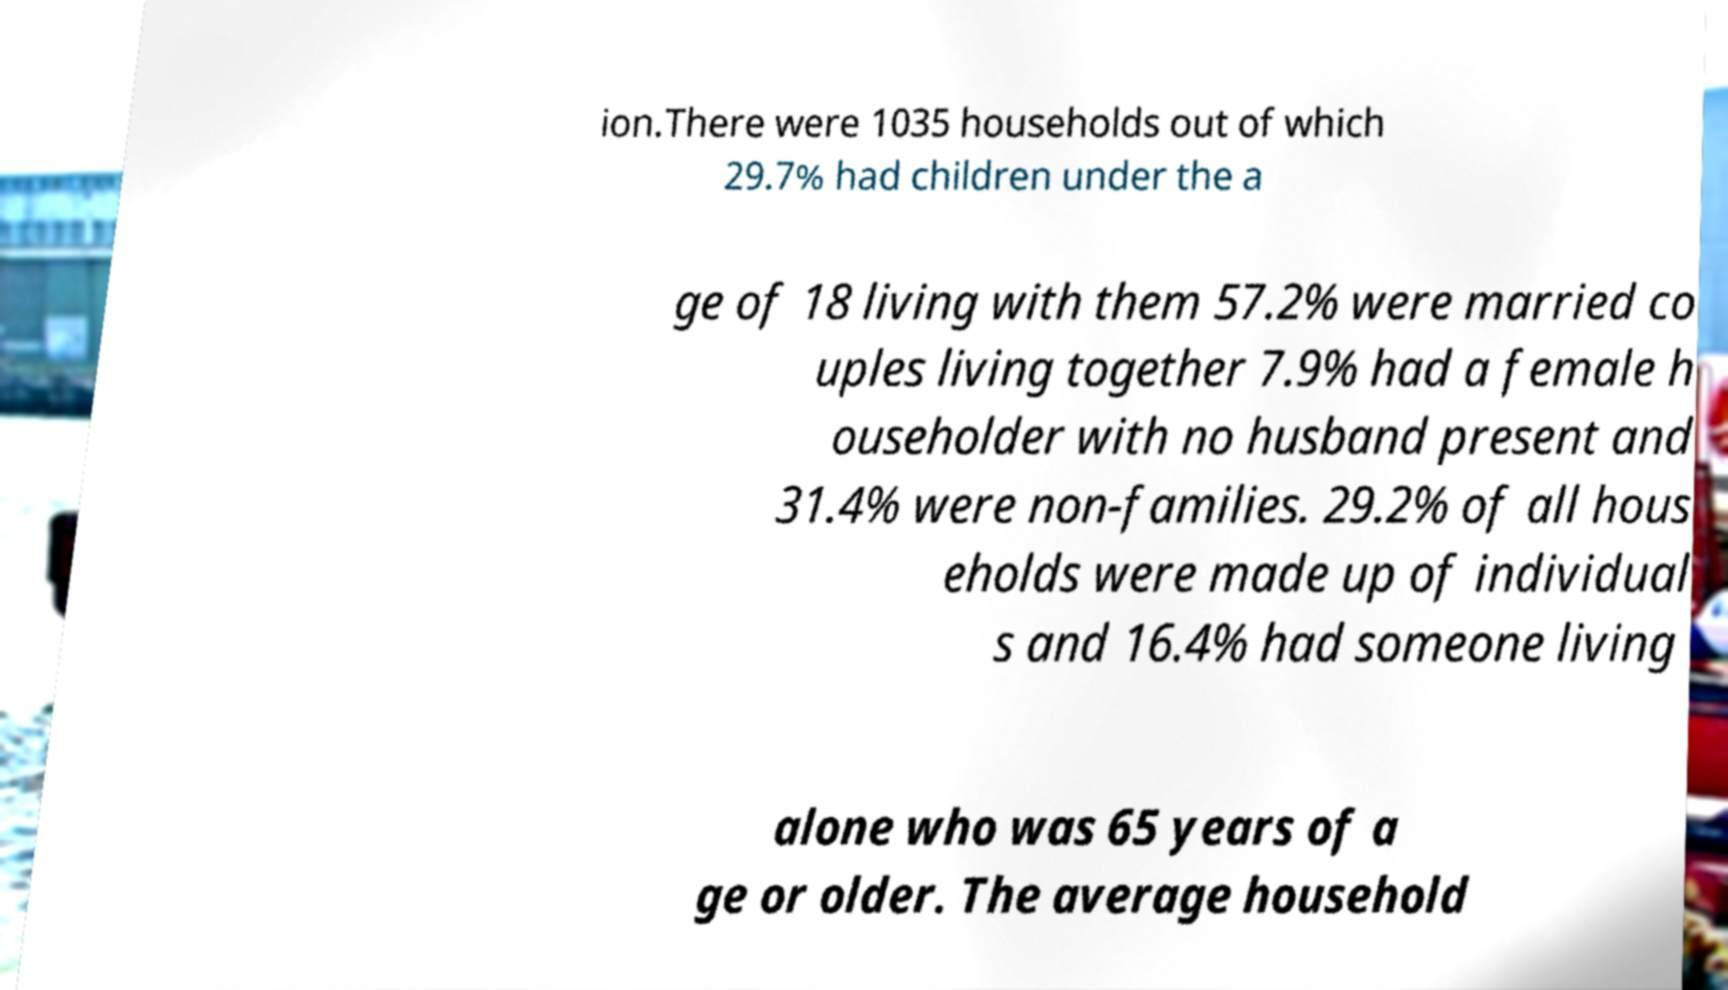Please read and relay the text visible in this image. What does it say? ion.There were 1035 households out of which 29.7% had children under the a ge of 18 living with them 57.2% were married co uples living together 7.9% had a female h ouseholder with no husband present and 31.4% were non-families. 29.2% of all hous eholds were made up of individual s and 16.4% had someone living alone who was 65 years of a ge or older. The average household 